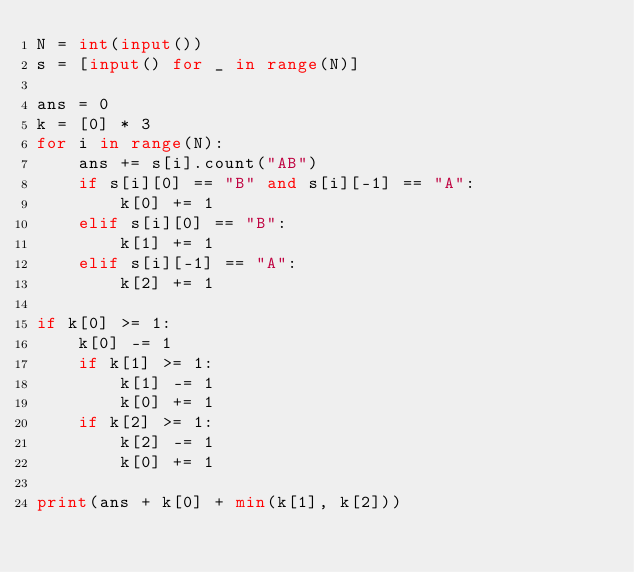<code> <loc_0><loc_0><loc_500><loc_500><_Python_>N = int(input())
s = [input() for _ in range(N)]

ans = 0
k = [0] * 3
for i in range(N):
    ans += s[i].count("AB")
    if s[i][0] == "B" and s[i][-1] == "A":
        k[0] += 1
    elif s[i][0] == "B":
        k[1] += 1
    elif s[i][-1] == "A":
        k[2] += 1

if k[0] >= 1:
    k[0] -= 1
    if k[1] >= 1:
        k[1] -= 1
        k[0] += 1
    if k[2] >= 1:
        k[2] -= 1
        k[0] += 1

print(ans + k[0] + min(k[1], k[2]))</code> 